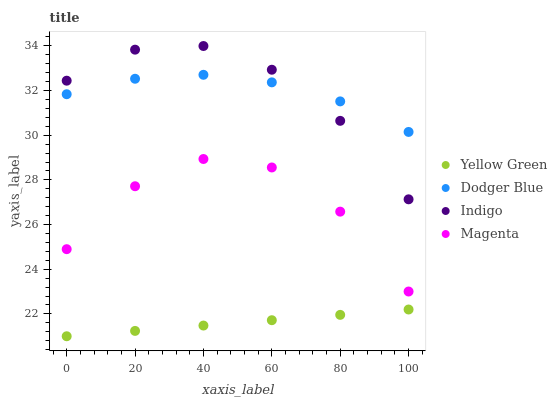Does Yellow Green have the minimum area under the curve?
Answer yes or no. Yes. Does Indigo have the maximum area under the curve?
Answer yes or no. Yes. Does Magenta have the minimum area under the curve?
Answer yes or no. No. Does Magenta have the maximum area under the curve?
Answer yes or no. No. Is Yellow Green the smoothest?
Answer yes or no. Yes. Is Magenta the roughest?
Answer yes or no. Yes. Is Dodger Blue the smoothest?
Answer yes or no. No. Is Dodger Blue the roughest?
Answer yes or no. No. Does Yellow Green have the lowest value?
Answer yes or no. Yes. Does Magenta have the lowest value?
Answer yes or no. No. Does Indigo have the highest value?
Answer yes or no. Yes. Does Magenta have the highest value?
Answer yes or no. No. Is Yellow Green less than Magenta?
Answer yes or no. Yes. Is Magenta greater than Yellow Green?
Answer yes or no. Yes. Does Dodger Blue intersect Indigo?
Answer yes or no. Yes. Is Dodger Blue less than Indigo?
Answer yes or no. No. Is Dodger Blue greater than Indigo?
Answer yes or no. No. Does Yellow Green intersect Magenta?
Answer yes or no. No. 